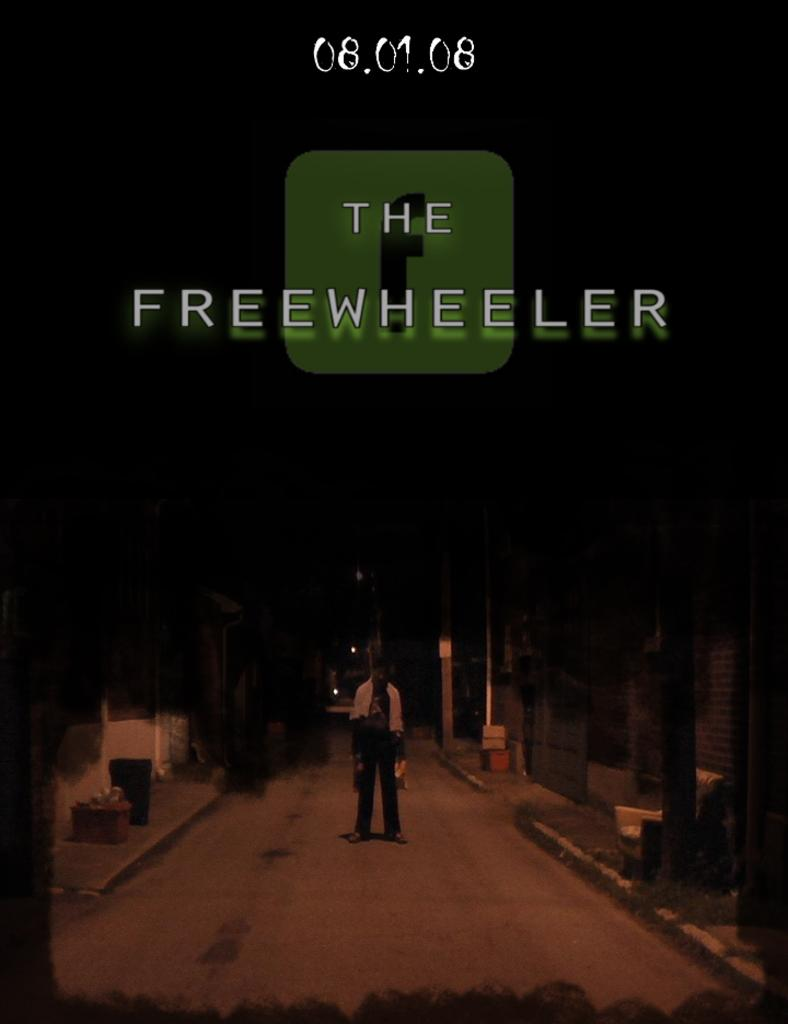<image>
Describe the image concisely. A poster for The Freewheeler available on 08.01.08 